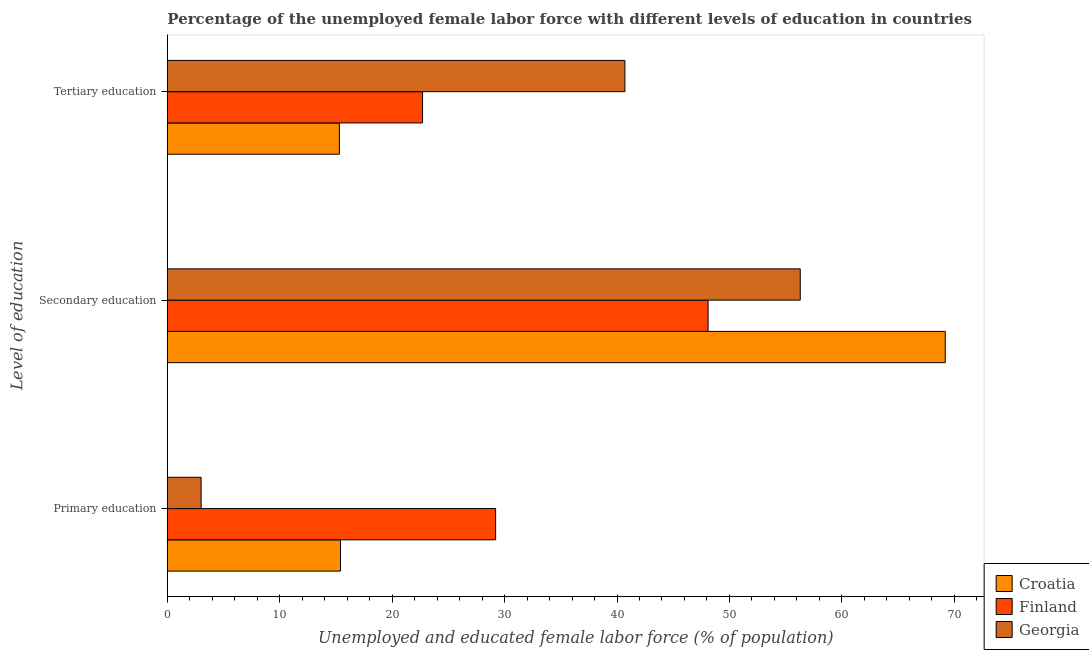How many different coloured bars are there?
Offer a very short reply. 3. How many groups of bars are there?
Offer a terse response. 3. Are the number of bars on each tick of the Y-axis equal?
Provide a short and direct response. Yes. How many bars are there on the 3rd tick from the top?
Give a very brief answer. 3. How many bars are there on the 3rd tick from the bottom?
Provide a succinct answer. 3. What is the label of the 1st group of bars from the top?
Make the answer very short. Tertiary education. What is the percentage of female labor force who received primary education in Croatia?
Provide a succinct answer. 15.4. Across all countries, what is the maximum percentage of female labor force who received primary education?
Your answer should be compact. 29.2. Across all countries, what is the minimum percentage of female labor force who received secondary education?
Provide a succinct answer. 48.1. In which country was the percentage of female labor force who received tertiary education minimum?
Give a very brief answer. Croatia. What is the total percentage of female labor force who received primary education in the graph?
Your answer should be compact. 47.6. What is the difference between the percentage of female labor force who received tertiary education in Finland and that in Georgia?
Provide a succinct answer. -18. What is the difference between the percentage of female labor force who received tertiary education in Croatia and the percentage of female labor force who received primary education in Georgia?
Your answer should be very brief. 12.3. What is the average percentage of female labor force who received tertiary education per country?
Make the answer very short. 26.23. What is the difference between the percentage of female labor force who received tertiary education and percentage of female labor force who received secondary education in Georgia?
Provide a short and direct response. -15.6. What is the ratio of the percentage of female labor force who received secondary education in Finland to that in Georgia?
Provide a succinct answer. 0.85. Is the difference between the percentage of female labor force who received secondary education in Finland and Croatia greater than the difference between the percentage of female labor force who received primary education in Finland and Croatia?
Give a very brief answer. No. What is the difference between the highest and the second highest percentage of female labor force who received secondary education?
Your answer should be very brief. 12.9. What is the difference between the highest and the lowest percentage of female labor force who received primary education?
Offer a terse response. 26.2. In how many countries, is the percentage of female labor force who received tertiary education greater than the average percentage of female labor force who received tertiary education taken over all countries?
Your answer should be compact. 1. What does the 2nd bar from the top in Tertiary education represents?
Provide a succinct answer. Finland. What does the 2nd bar from the bottom in Primary education represents?
Your response must be concise. Finland. Is it the case that in every country, the sum of the percentage of female labor force who received primary education and percentage of female labor force who received secondary education is greater than the percentage of female labor force who received tertiary education?
Offer a very short reply. Yes. Are all the bars in the graph horizontal?
Ensure brevity in your answer.  Yes. Are the values on the major ticks of X-axis written in scientific E-notation?
Your answer should be compact. No. Does the graph contain any zero values?
Offer a very short reply. No. How many legend labels are there?
Provide a succinct answer. 3. What is the title of the graph?
Your answer should be compact. Percentage of the unemployed female labor force with different levels of education in countries. What is the label or title of the X-axis?
Your response must be concise. Unemployed and educated female labor force (% of population). What is the label or title of the Y-axis?
Ensure brevity in your answer.  Level of education. What is the Unemployed and educated female labor force (% of population) of Croatia in Primary education?
Give a very brief answer. 15.4. What is the Unemployed and educated female labor force (% of population) in Finland in Primary education?
Make the answer very short. 29.2. What is the Unemployed and educated female labor force (% of population) in Croatia in Secondary education?
Your answer should be very brief. 69.2. What is the Unemployed and educated female labor force (% of population) of Finland in Secondary education?
Ensure brevity in your answer.  48.1. What is the Unemployed and educated female labor force (% of population) in Georgia in Secondary education?
Your response must be concise. 56.3. What is the Unemployed and educated female labor force (% of population) of Croatia in Tertiary education?
Ensure brevity in your answer.  15.3. What is the Unemployed and educated female labor force (% of population) of Finland in Tertiary education?
Make the answer very short. 22.7. What is the Unemployed and educated female labor force (% of population) of Georgia in Tertiary education?
Keep it short and to the point. 40.7. Across all Level of education, what is the maximum Unemployed and educated female labor force (% of population) in Croatia?
Offer a very short reply. 69.2. Across all Level of education, what is the maximum Unemployed and educated female labor force (% of population) of Finland?
Offer a very short reply. 48.1. Across all Level of education, what is the maximum Unemployed and educated female labor force (% of population) of Georgia?
Provide a succinct answer. 56.3. Across all Level of education, what is the minimum Unemployed and educated female labor force (% of population) of Croatia?
Offer a terse response. 15.3. Across all Level of education, what is the minimum Unemployed and educated female labor force (% of population) in Finland?
Ensure brevity in your answer.  22.7. What is the total Unemployed and educated female labor force (% of population) in Croatia in the graph?
Your answer should be compact. 99.9. What is the total Unemployed and educated female labor force (% of population) of Finland in the graph?
Make the answer very short. 100. What is the difference between the Unemployed and educated female labor force (% of population) in Croatia in Primary education and that in Secondary education?
Provide a short and direct response. -53.8. What is the difference between the Unemployed and educated female labor force (% of population) of Finland in Primary education and that in Secondary education?
Your answer should be very brief. -18.9. What is the difference between the Unemployed and educated female labor force (% of population) in Georgia in Primary education and that in Secondary education?
Ensure brevity in your answer.  -53.3. What is the difference between the Unemployed and educated female labor force (% of population) in Croatia in Primary education and that in Tertiary education?
Offer a terse response. 0.1. What is the difference between the Unemployed and educated female labor force (% of population) in Finland in Primary education and that in Tertiary education?
Provide a succinct answer. 6.5. What is the difference between the Unemployed and educated female labor force (% of population) in Georgia in Primary education and that in Tertiary education?
Provide a short and direct response. -37.7. What is the difference between the Unemployed and educated female labor force (% of population) in Croatia in Secondary education and that in Tertiary education?
Make the answer very short. 53.9. What is the difference between the Unemployed and educated female labor force (% of population) in Finland in Secondary education and that in Tertiary education?
Give a very brief answer. 25.4. What is the difference between the Unemployed and educated female labor force (% of population) of Georgia in Secondary education and that in Tertiary education?
Offer a terse response. 15.6. What is the difference between the Unemployed and educated female labor force (% of population) of Croatia in Primary education and the Unemployed and educated female labor force (% of population) of Finland in Secondary education?
Your response must be concise. -32.7. What is the difference between the Unemployed and educated female labor force (% of population) of Croatia in Primary education and the Unemployed and educated female labor force (% of population) of Georgia in Secondary education?
Give a very brief answer. -40.9. What is the difference between the Unemployed and educated female labor force (% of population) of Finland in Primary education and the Unemployed and educated female labor force (% of population) of Georgia in Secondary education?
Give a very brief answer. -27.1. What is the difference between the Unemployed and educated female labor force (% of population) of Croatia in Primary education and the Unemployed and educated female labor force (% of population) of Finland in Tertiary education?
Keep it short and to the point. -7.3. What is the difference between the Unemployed and educated female labor force (% of population) in Croatia in Primary education and the Unemployed and educated female labor force (% of population) in Georgia in Tertiary education?
Offer a terse response. -25.3. What is the difference between the Unemployed and educated female labor force (% of population) in Finland in Primary education and the Unemployed and educated female labor force (% of population) in Georgia in Tertiary education?
Your response must be concise. -11.5. What is the difference between the Unemployed and educated female labor force (% of population) of Croatia in Secondary education and the Unemployed and educated female labor force (% of population) of Finland in Tertiary education?
Make the answer very short. 46.5. What is the average Unemployed and educated female labor force (% of population) in Croatia per Level of education?
Your answer should be compact. 33.3. What is the average Unemployed and educated female labor force (% of population) of Finland per Level of education?
Ensure brevity in your answer.  33.33. What is the average Unemployed and educated female labor force (% of population) of Georgia per Level of education?
Provide a short and direct response. 33.33. What is the difference between the Unemployed and educated female labor force (% of population) in Croatia and Unemployed and educated female labor force (% of population) in Georgia in Primary education?
Your response must be concise. 12.4. What is the difference between the Unemployed and educated female labor force (% of population) of Finland and Unemployed and educated female labor force (% of population) of Georgia in Primary education?
Provide a short and direct response. 26.2. What is the difference between the Unemployed and educated female labor force (% of population) in Croatia and Unemployed and educated female labor force (% of population) in Finland in Secondary education?
Provide a succinct answer. 21.1. What is the difference between the Unemployed and educated female labor force (% of population) in Croatia and Unemployed and educated female labor force (% of population) in Georgia in Secondary education?
Keep it short and to the point. 12.9. What is the difference between the Unemployed and educated female labor force (% of population) of Croatia and Unemployed and educated female labor force (% of population) of Finland in Tertiary education?
Offer a very short reply. -7.4. What is the difference between the Unemployed and educated female labor force (% of population) in Croatia and Unemployed and educated female labor force (% of population) in Georgia in Tertiary education?
Provide a short and direct response. -25.4. What is the difference between the Unemployed and educated female labor force (% of population) in Finland and Unemployed and educated female labor force (% of population) in Georgia in Tertiary education?
Provide a succinct answer. -18. What is the ratio of the Unemployed and educated female labor force (% of population) of Croatia in Primary education to that in Secondary education?
Offer a very short reply. 0.22. What is the ratio of the Unemployed and educated female labor force (% of population) in Finland in Primary education to that in Secondary education?
Your answer should be compact. 0.61. What is the ratio of the Unemployed and educated female labor force (% of population) of Georgia in Primary education to that in Secondary education?
Offer a terse response. 0.05. What is the ratio of the Unemployed and educated female labor force (% of population) in Finland in Primary education to that in Tertiary education?
Provide a succinct answer. 1.29. What is the ratio of the Unemployed and educated female labor force (% of population) in Georgia in Primary education to that in Tertiary education?
Offer a terse response. 0.07. What is the ratio of the Unemployed and educated female labor force (% of population) of Croatia in Secondary education to that in Tertiary education?
Your answer should be very brief. 4.52. What is the ratio of the Unemployed and educated female labor force (% of population) in Finland in Secondary education to that in Tertiary education?
Offer a very short reply. 2.12. What is the ratio of the Unemployed and educated female labor force (% of population) of Georgia in Secondary education to that in Tertiary education?
Offer a very short reply. 1.38. What is the difference between the highest and the second highest Unemployed and educated female labor force (% of population) in Croatia?
Provide a succinct answer. 53.8. What is the difference between the highest and the second highest Unemployed and educated female labor force (% of population) in Finland?
Keep it short and to the point. 18.9. What is the difference between the highest and the lowest Unemployed and educated female labor force (% of population) of Croatia?
Make the answer very short. 53.9. What is the difference between the highest and the lowest Unemployed and educated female labor force (% of population) of Finland?
Provide a succinct answer. 25.4. What is the difference between the highest and the lowest Unemployed and educated female labor force (% of population) in Georgia?
Make the answer very short. 53.3. 